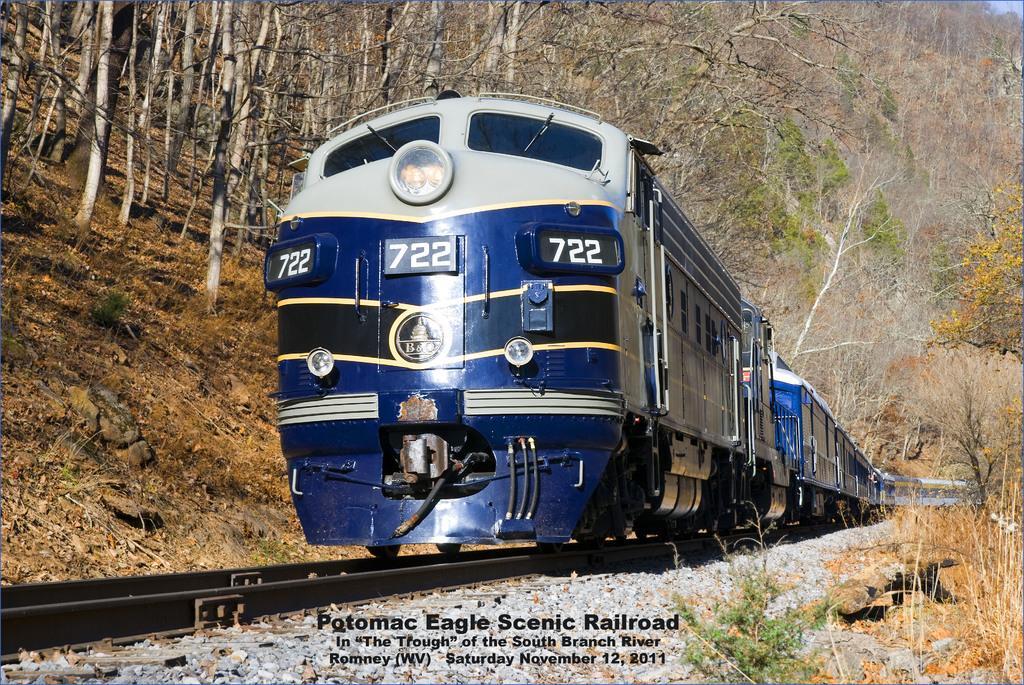Could you give a brief overview of what you see in this image? In this image, there is a train on the track. At the bottom of the image, we can see some text, stones and plants. In the background, there are so many trees, plants and stones. 